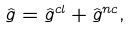<formula> <loc_0><loc_0><loc_500><loc_500>\hat { g } = \hat { g } ^ { c l } + \hat { g } ^ { n c } ,</formula> 